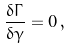<formula> <loc_0><loc_0><loc_500><loc_500>\frac { \delta \Gamma } { \delta \gamma } = 0 \, ,</formula> 